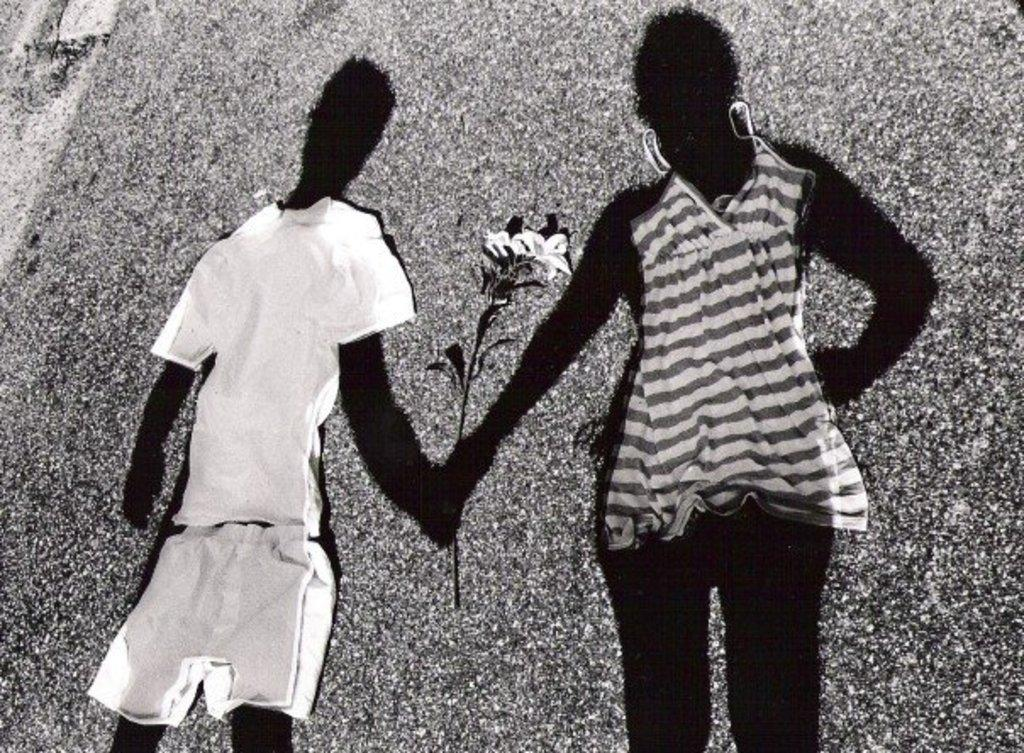What can be found on the ground in the image? There are clothes on the ground in the image. What else can be seen in the image besides the clothes? There are shadows of persons and a shadow of a flower in the image. Can you tell me how many birds are sitting on the clothes in the image? There are no birds present in the image; it only features clothes on the ground, shadows of persons, and a shadow of a flower. 